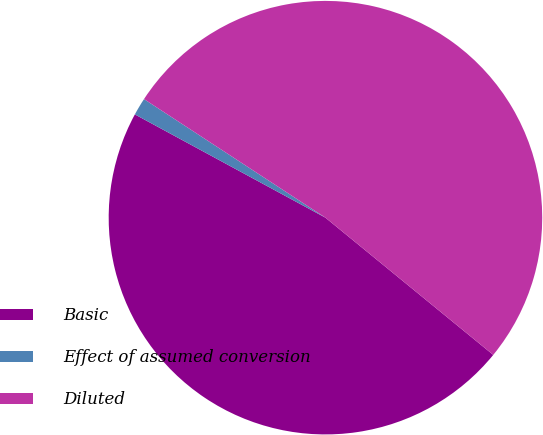Convert chart to OTSL. <chart><loc_0><loc_0><loc_500><loc_500><pie_chart><fcel>Basic<fcel>Effect of assumed conversion<fcel>Diluted<nl><fcel>47.0%<fcel>1.31%<fcel>51.7%<nl></chart> 